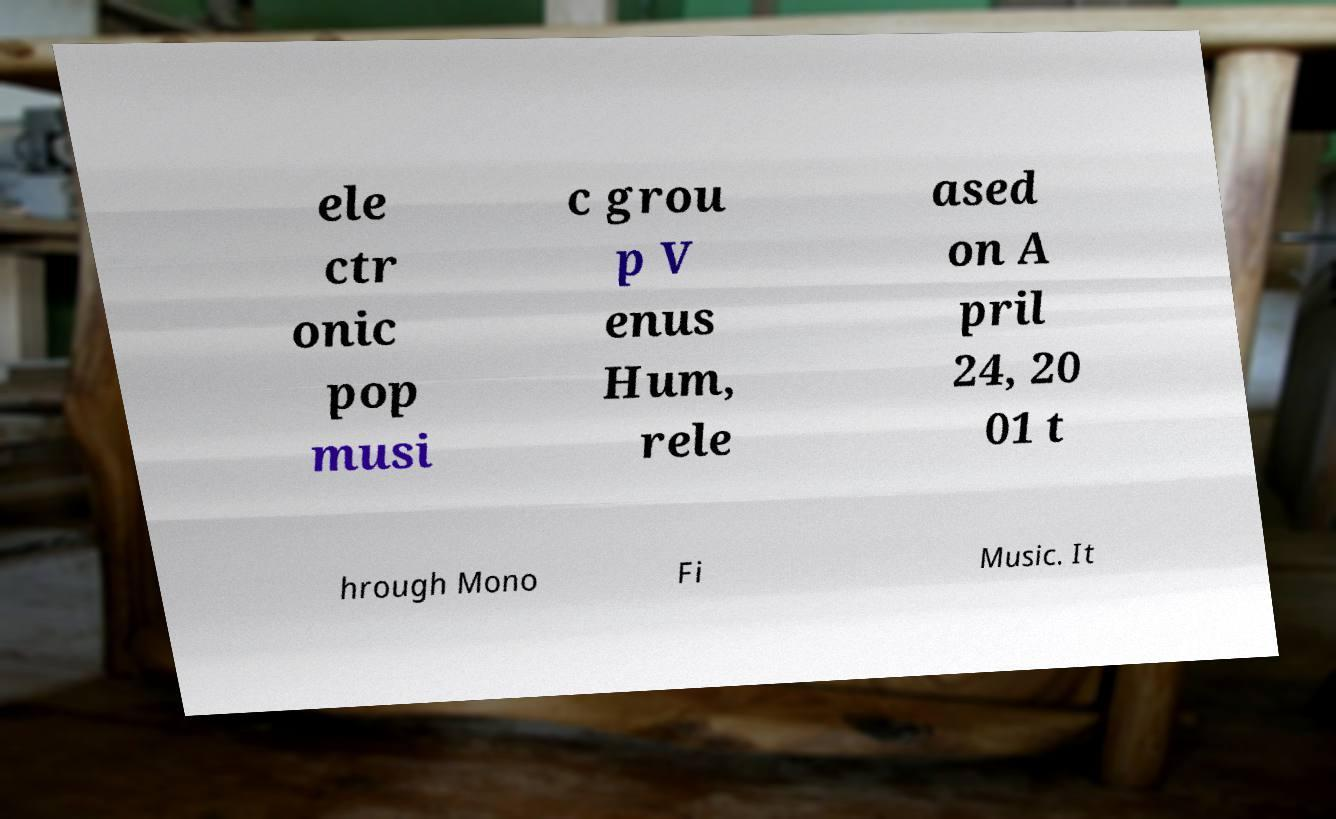Can you accurately transcribe the text from the provided image for me? ele ctr onic pop musi c grou p V enus Hum, rele ased on A pril 24, 20 01 t hrough Mono Fi Music. It 